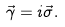Convert formula to latex. <formula><loc_0><loc_0><loc_500><loc_500>\vec { \gamma } = i \vec { \sigma } .</formula> 